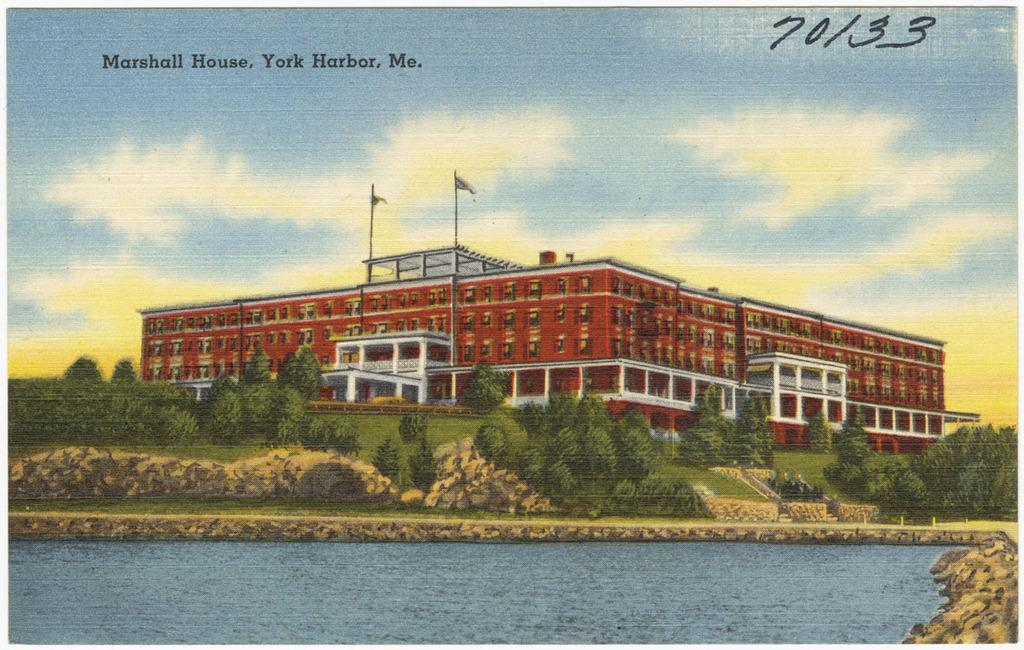Provide a one-sentence caption for the provided image. A picture of a large red building with water in front called  the Marshall House in York Harbor, Maine.of. 